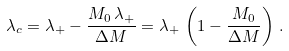<formula> <loc_0><loc_0><loc_500><loc_500>\lambda _ { c } = \lambda _ { + } - \frac { M _ { 0 } \, \lambda _ { + } } { \Delta M } = \lambda _ { + } \, \left ( 1 - \frac { M _ { 0 } } { \Delta M } \right ) \, .</formula> 